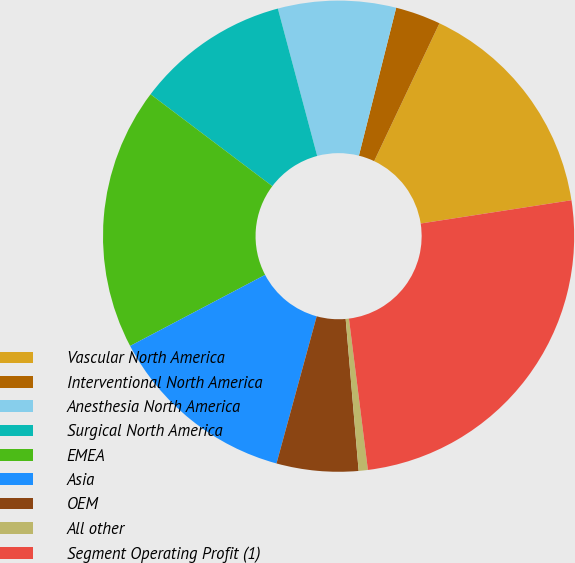Convert chart to OTSL. <chart><loc_0><loc_0><loc_500><loc_500><pie_chart><fcel>Vascular North America<fcel>Interventional North America<fcel>Anesthesia North America<fcel>Surgical North America<fcel>EMEA<fcel>Asia<fcel>OEM<fcel>All other<fcel>Segment Operating Profit (1)<nl><fcel>15.52%<fcel>3.11%<fcel>8.08%<fcel>10.56%<fcel>18.0%<fcel>13.04%<fcel>5.6%<fcel>0.63%<fcel>25.45%<nl></chart> 